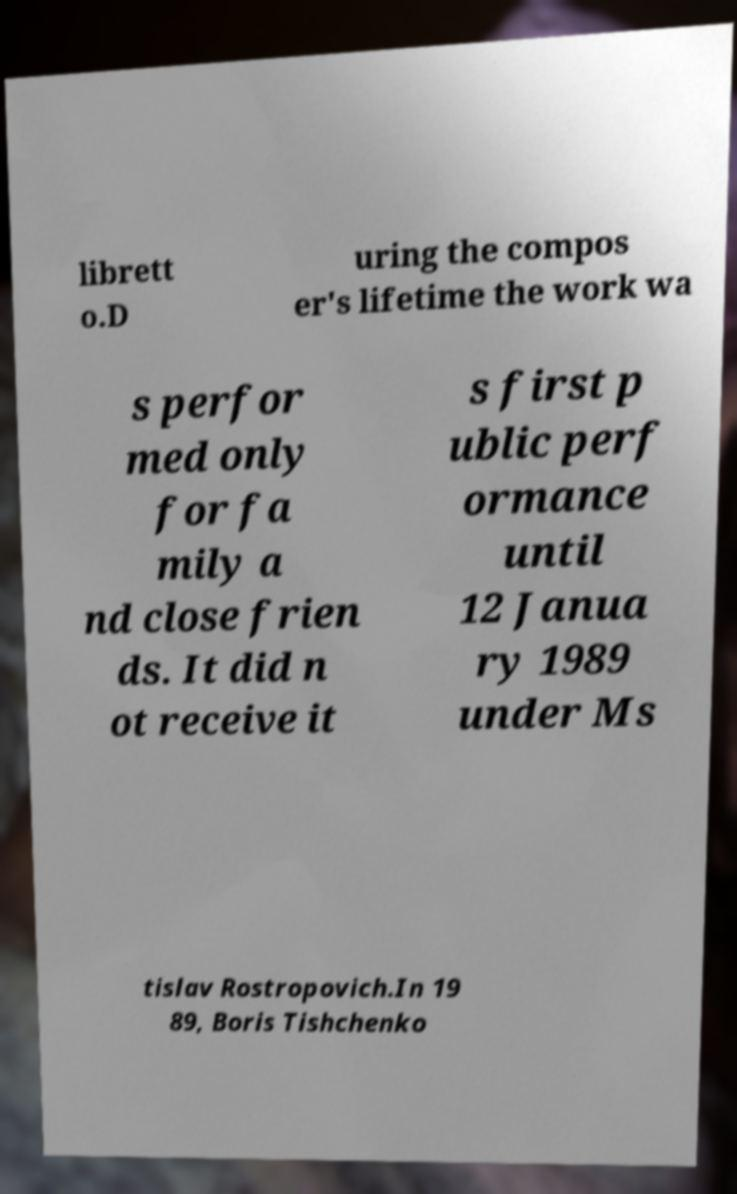Can you accurately transcribe the text from the provided image for me? librett o.D uring the compos er's lifetime the work wa s perfor med only for fa mily a nd close frien ds. It did n ot receive it s first p ublic perf ormance until 12 Janua ry 1989 under Ms tislav Rostropovich.In 19 89, Boris Tishchenko 